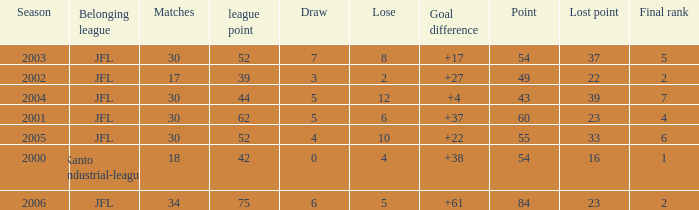I want the average lose for lost point more than 16 and goal difference less than 37 and point less than 43 None. 